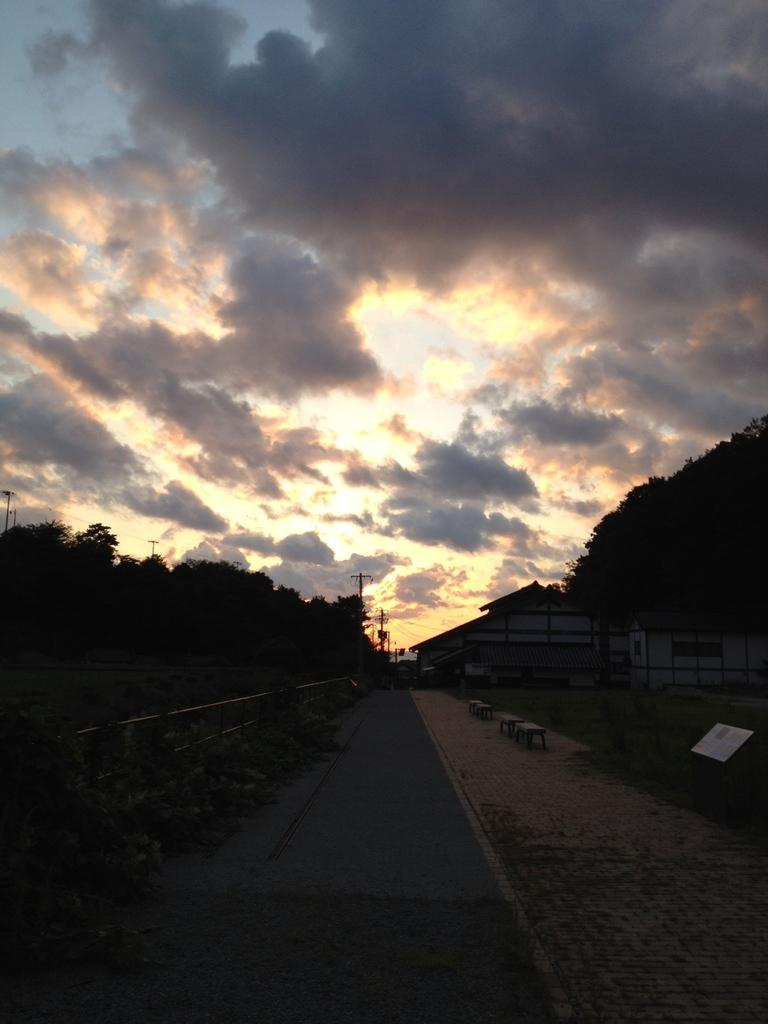What is the main feature of the image? There is a road in the image. What objects are near the road? There are boards and a railing near the road. What can be seen in the background of the image? There is a house, many trees, poles, clouds, and the sky visible in the background of the image. What month is it in the image? The month cannot be determined from the image, as there is no information about the time of year. Is there a train passing by in the image? There is no train present in the image. 